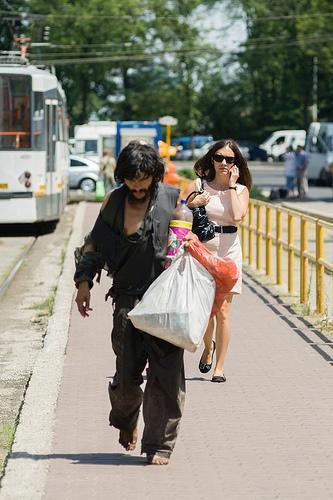How many people are pictured?
Give a very brief answer. 2. 